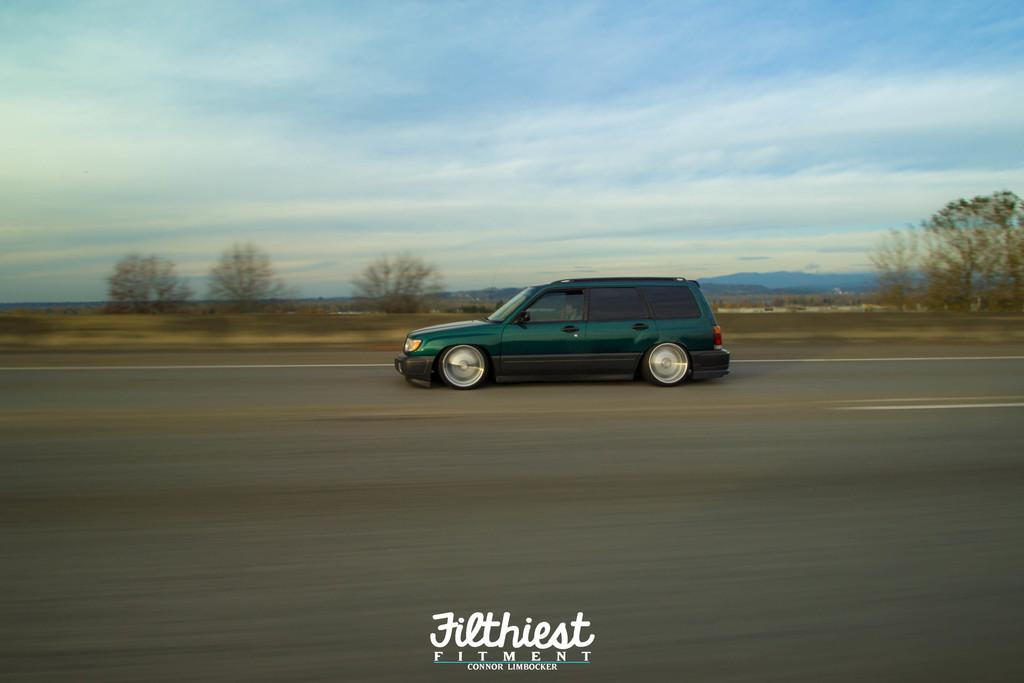What color is the vehicle in the image? The vehicle in the image is green. Where is the vehicle located? The vehicle is on the road. What can be seen in the background of the image? In the background of the image, there are many trees, mountains, clouds, and the sky. What time of day is it in the image, and how does the vehicle's brake system work? The time of day is not mentioned in the image, and there is no information about the vehicle's brake system. 